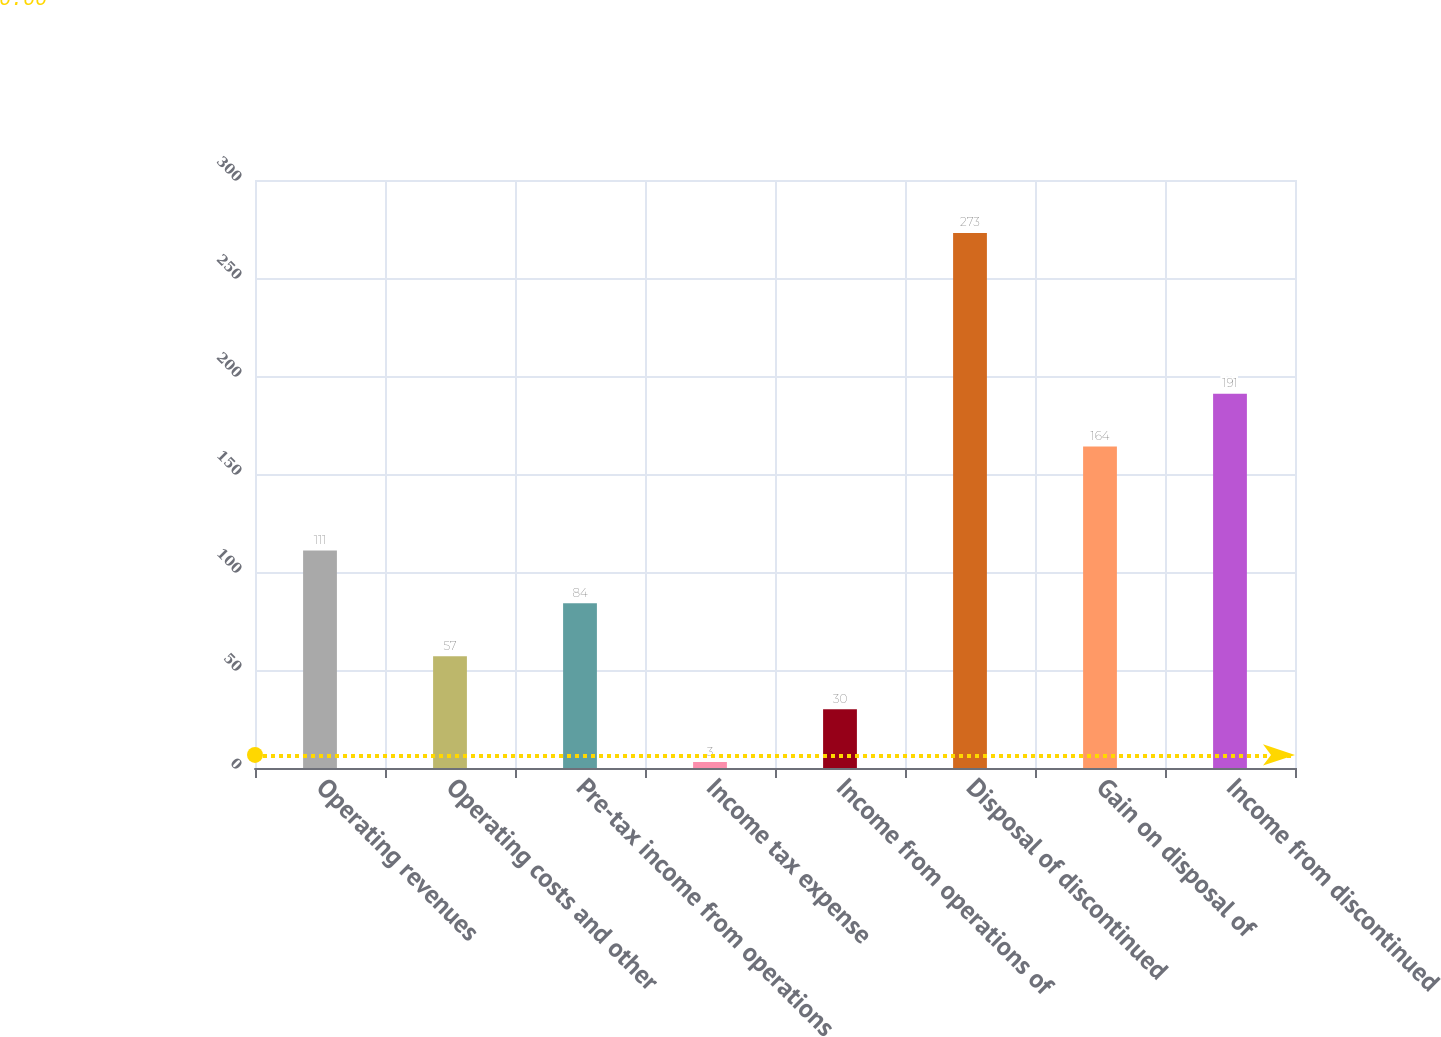Convert chart. <chart><loc_0><loc_0><loc_500><loc_500><bar_chart><fcel>Operating revenues<fcel>Operating costs and other<fcel>Pre-tax income from operations<fcel>Income tax expense<fcel>Income from operations of<fcel>Disposal of discontinued<fcel>Gain on disposal of<fcel>Income from discontinued<nl><fcel>111<fcel>57<fcel>84<fcel>3<fcel>30<fcel>273<fcel>164<fcel>191<nl></chart> 